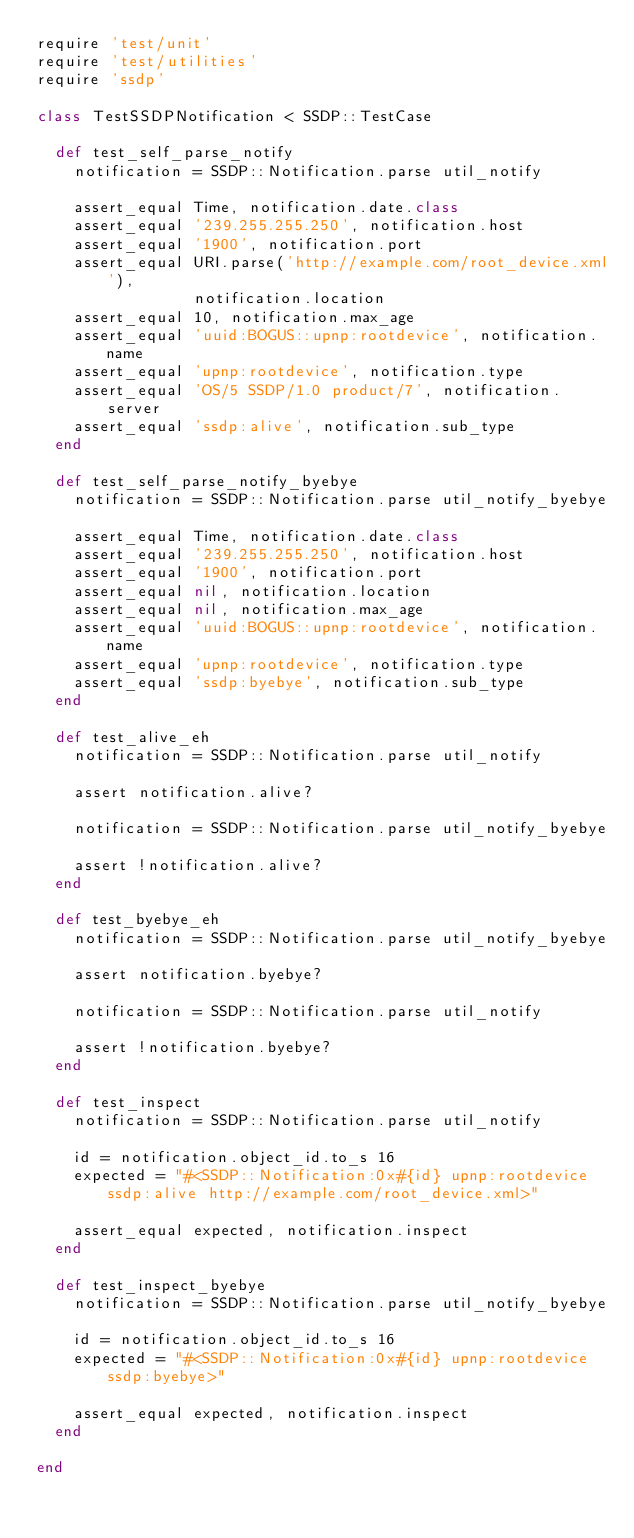<code> <loc_0><loc_0><loc_500><loc_500><_Ruby_>require 'test/unit'
require 'test/utilities'
require 'ssdp'

class TestSSDPNotification < SSDP::TestCase

  def test_self_parse_notify
    notification = SSDP::Notification.parse util_notify

    assert_equal Time, notification.date.class
    assert_equal '239.255.255.250', notification.host
    assert_equal '1900', notification.port
    assert_equal URI.parse('http://example.com/root_device.xml'),
                 notification.location
    assert_equal 10, notification.max_age
    assert_equal 'uuid:BOGUS::upnp:rootdevice', notification.name
    assert_equal 'upnp:rootdevice', notification.type
    assert_equal 'OS/5 SSDP/1.0 product/7', notification.server
    assert_equal 'ssdp:alive', notification.sub_type
  end

  def test_self_parse_notify_byebye
    notification = SSDP::Notification.parse util_notify_byebye

    assert_equal Time, notification.date.class
    assert_equal '239.255.255.250', notification.host
    assert_equal '1900', notification.port
    assert_equal nil, notification.location
    assert_equal nil, notification.max_age
    assert_equal 'uuid:BOGUS::upnp:rootdevice', notification.name
    assert_equal 'upnp:rootdevice', notification.type
    assert_equal 'ssdp:byebye', notification.sub_type
  end

  def test_alive_eh
    notification = SSDP::Notification.parse util_notify

    assert notification.alive?

    notification = SSDP::Notification.parse util_notify_byebye

    assert !notification.alive?
  end

  def test_byebye_eh
    notification = SSDP::Notification.parse util_notify_byebye

    assert notification.byebye?

    notification = SSDP::Notification.parse util_notify

    assert !notification.byebye?
  end

  def test_inspect
    notification = SSDP::Notification.parse util_notify

    id = notification.object_id.to_s 16
    expected = "#<SSDP::Notification:0x#{id} upnp:rootdevice ssdp:alive http://example.com/root_device.xml>"

    assert_equal expected, notification.inspect
  end

  def test_inspect_byebye
    notification = SSDP::Notification.parse util_notify_byebye

    id = notification.object_id.to_s 16
    expected = "#<SSDP::Notification:0x#{id} upnp:rootdevice ssdp:byebye>"

    assert_equal expected, notification.inspect
  end

end

</code> 